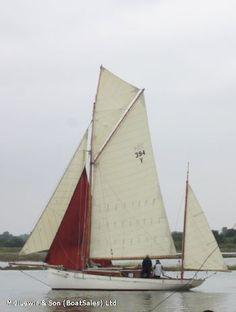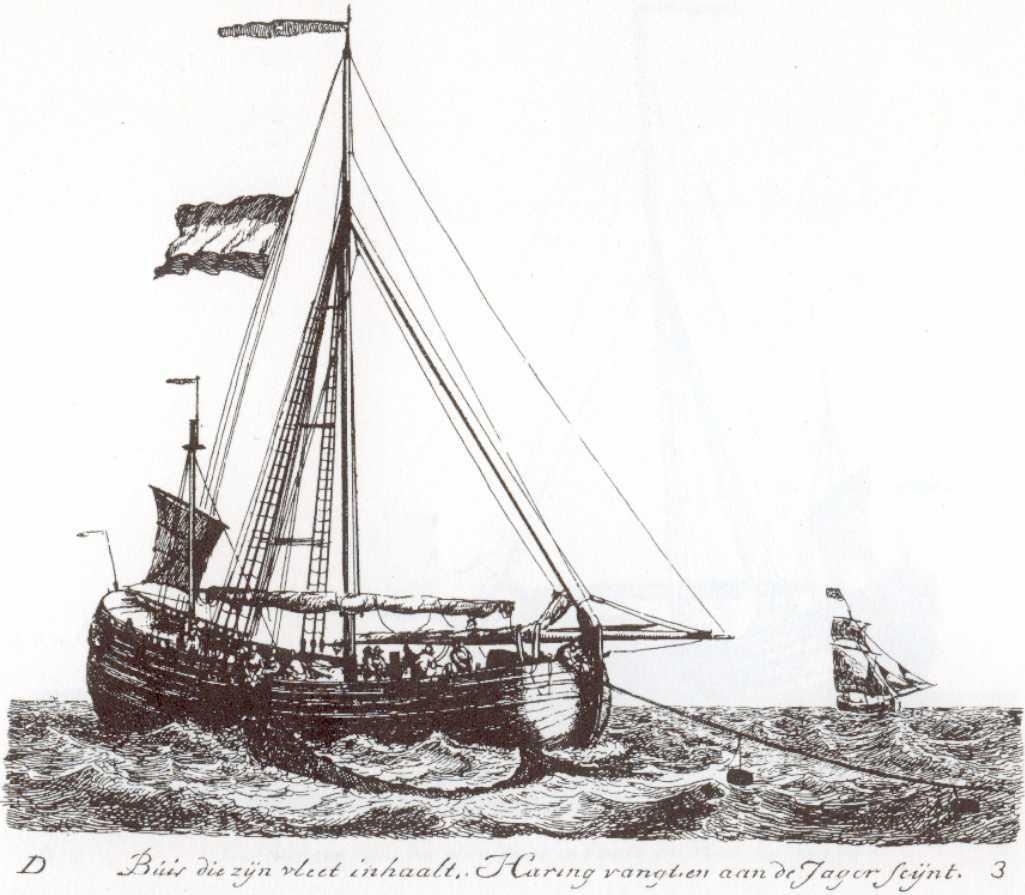The first image is the image on the left, the second image is the image on the right. Given the left and right images, does the statement "One of the boats has brown sails and a red bottom." hold true? Answer yes or no. No. 